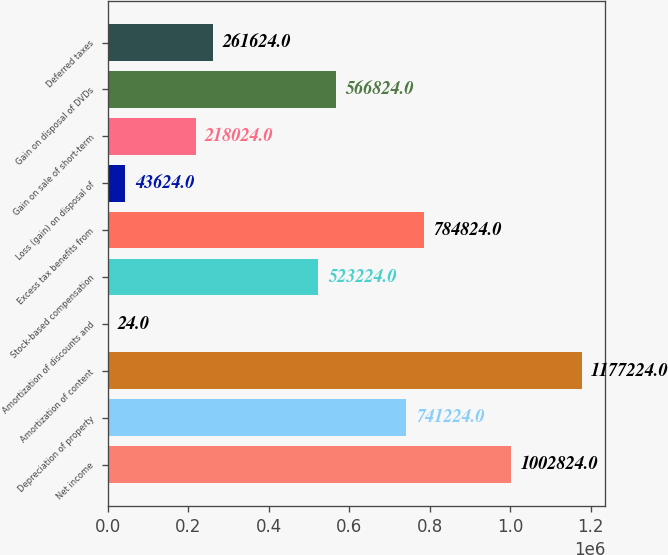Convert chart to OTSL. <chart><loc_0><loc_0><loc_500><loc_500><bar_chart><fcel>Net income<fcel>Depreciation of property<fcel>Amortization of content<fcel>Amortization of discounts and<fcel>Stock-based compensation<fcel>Excess tax benefits from<fcel>Loss (gain) on disposal of<fcel>Gain on sale of short-term<fcel>Gain on disposal of DVDs<fcel>Deferred taxes<nl><fcel>1.00282e+06<fcel>741224<fcel>1.17722e+06<fcel>24<fcel>523224<fcel>784824<fcel>43624<fcel>218024<fcel>566824<fcel>261624<nl></chart> 